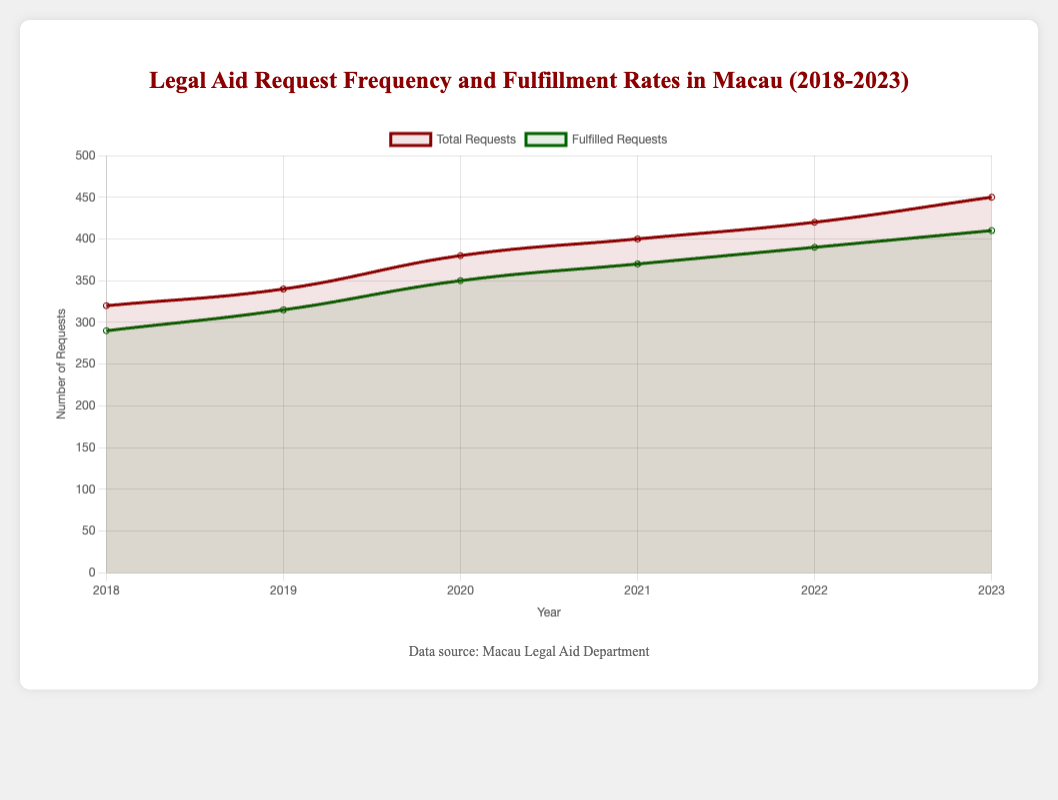What trend can be observed for total requests and fulfilled requests from 2018 to 2023? Observing the figure, there is an increasing trend for both total requests and fulfilled requests from 2018 to 2023. Each year, both metrics rise steadily without any decrease or plateau.
Answer: Increasing trend In which year did the fulfilled requests have the smallest gap compared to the total requests? To find the year with the smallest gap, we subtract the fulfilled requests from the total requests for each year. The smallest difference is in 2018 with 320 - 290 = 30.
Answer: 2018 What is the average number of total legal aid requests from 2018 to 2023? To find the average, add the total requests from each year and divide by the number of years: (320 + 340 + 380 + 400 + 420 + 450) / 6 = 385.
Answer: 385 How does the fulfillment rate change from 2018 to 2023? The fulfillment rate is calculated as the percentage of fulfilled requests out of total requests for each year and observing its trend. Fulfillment rates are as follows: 2018: ~90.6%, 2019: ~92.6%, 2020: ~92.1%, 2021: ~92.5%, 2022: ~92.9%, 2023: ~91.1%. The rate initially increases, slightly decreases, and then stabilizes around 92-93%, ending with a small decrease in 2023.
Answer: Slight fluctuation around 92-93% Which year has the highest fulfillment rate percentage-wise? Calculate the fulfillment rate for each year and compare: 2018: ~90.6%, 2019: ~92.6%, 2020: ~92.1%, 2021: ~92.5%, 2022: ~92.9%, 2023: ~91.1%. The highest rate is in 2022 with ~92.9%.
Answer: 2022 How does the visual representation indicate the trend in requests and fulfilled requests? The chart shows two lines, one for total requests (red) and another for fulfilled requests (green). Both lines slope upward over the years with the red line consistently above the green line, illustrating an increasing trend in both categories.
Answer: Upward sloping lines Compare the total increase in legal aid requests and fulfilled requests from 2018 to 2023. Total requests increased from 320 to 450 (an increase of 130). Fulfilled requests increased from 290 to 410 (an increase of 120).
Answer: Total requests: 130, Fulfilled requests: 120 Is there any year where the number of fulfilled requests did not increase compared to the previous year? By comparing fulfilled requests year by year, all years (2018: 290, 2019: 315, 2020: 350, 2021: 370, 2022: 390, 2023: 410) show an increase from the preceding year.
Answer: No 